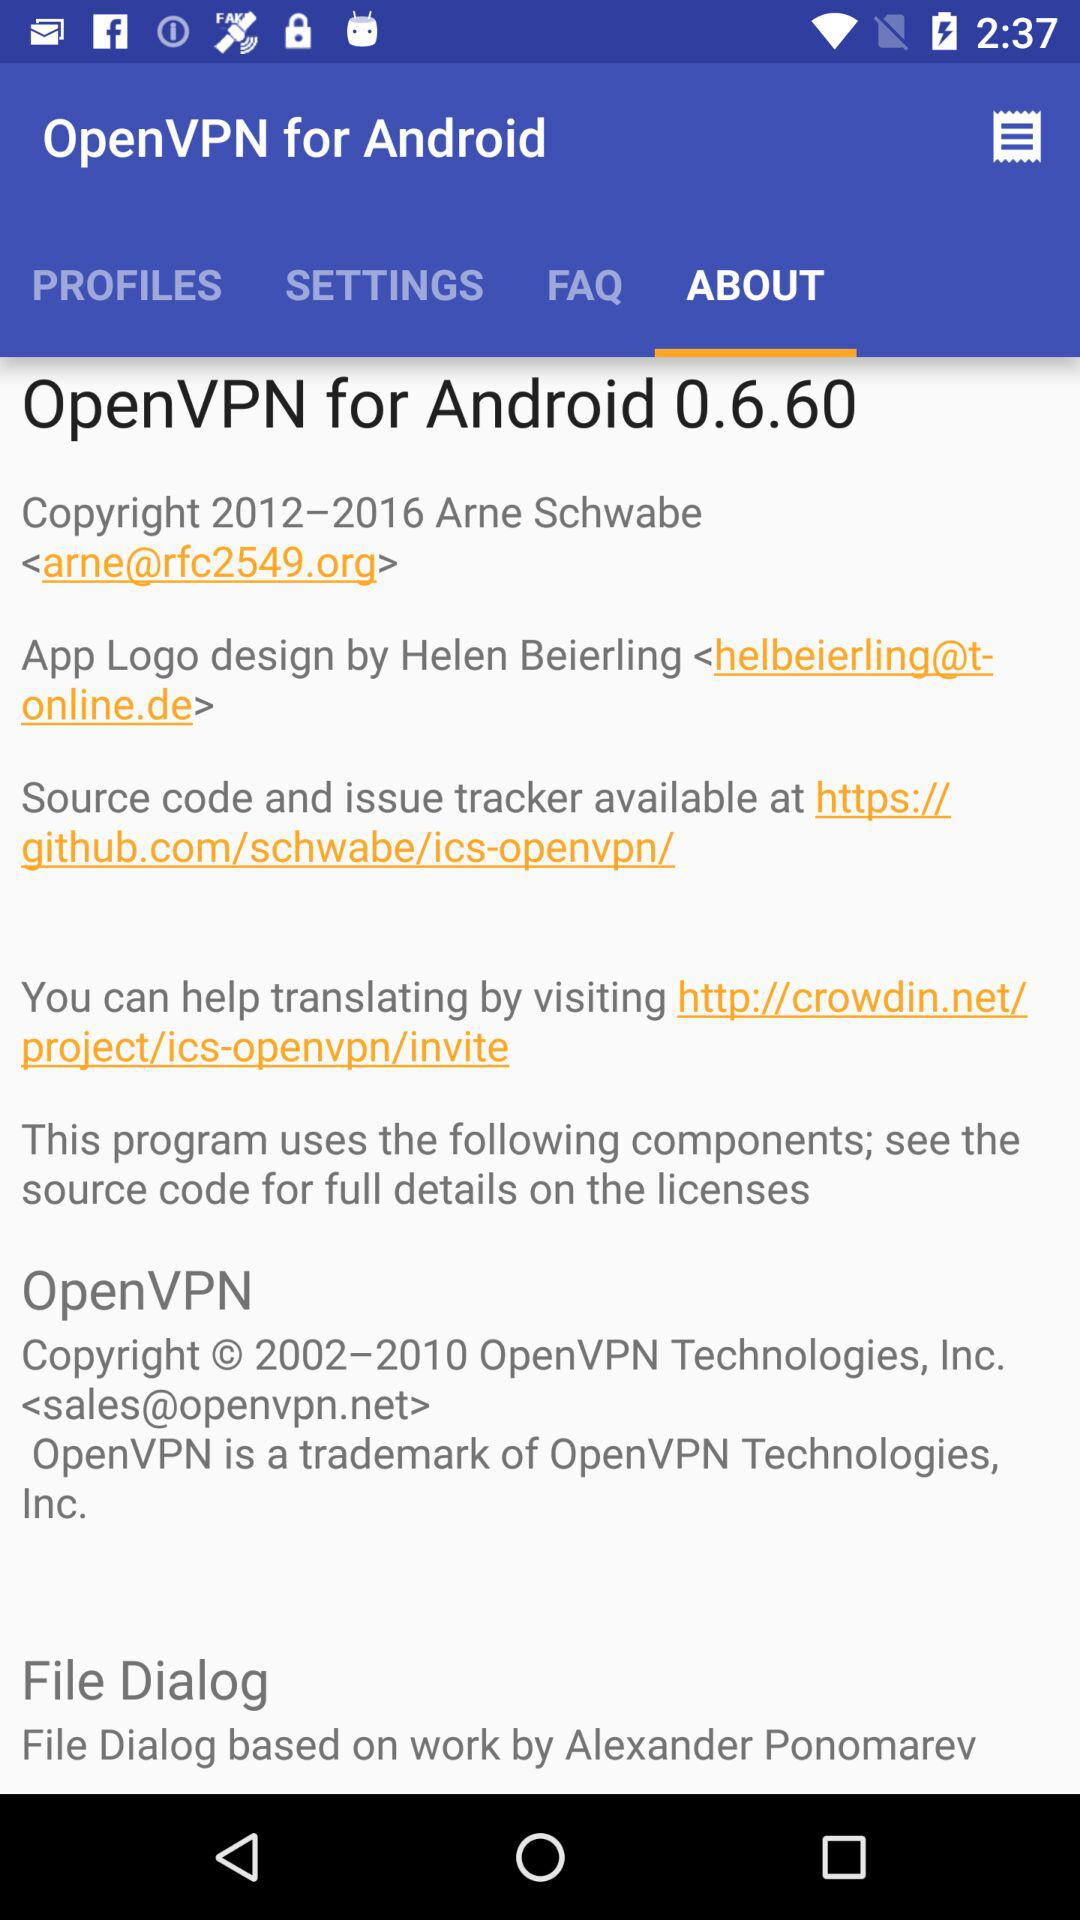Which tab am I on? You are on the "ABOUT" tab. 